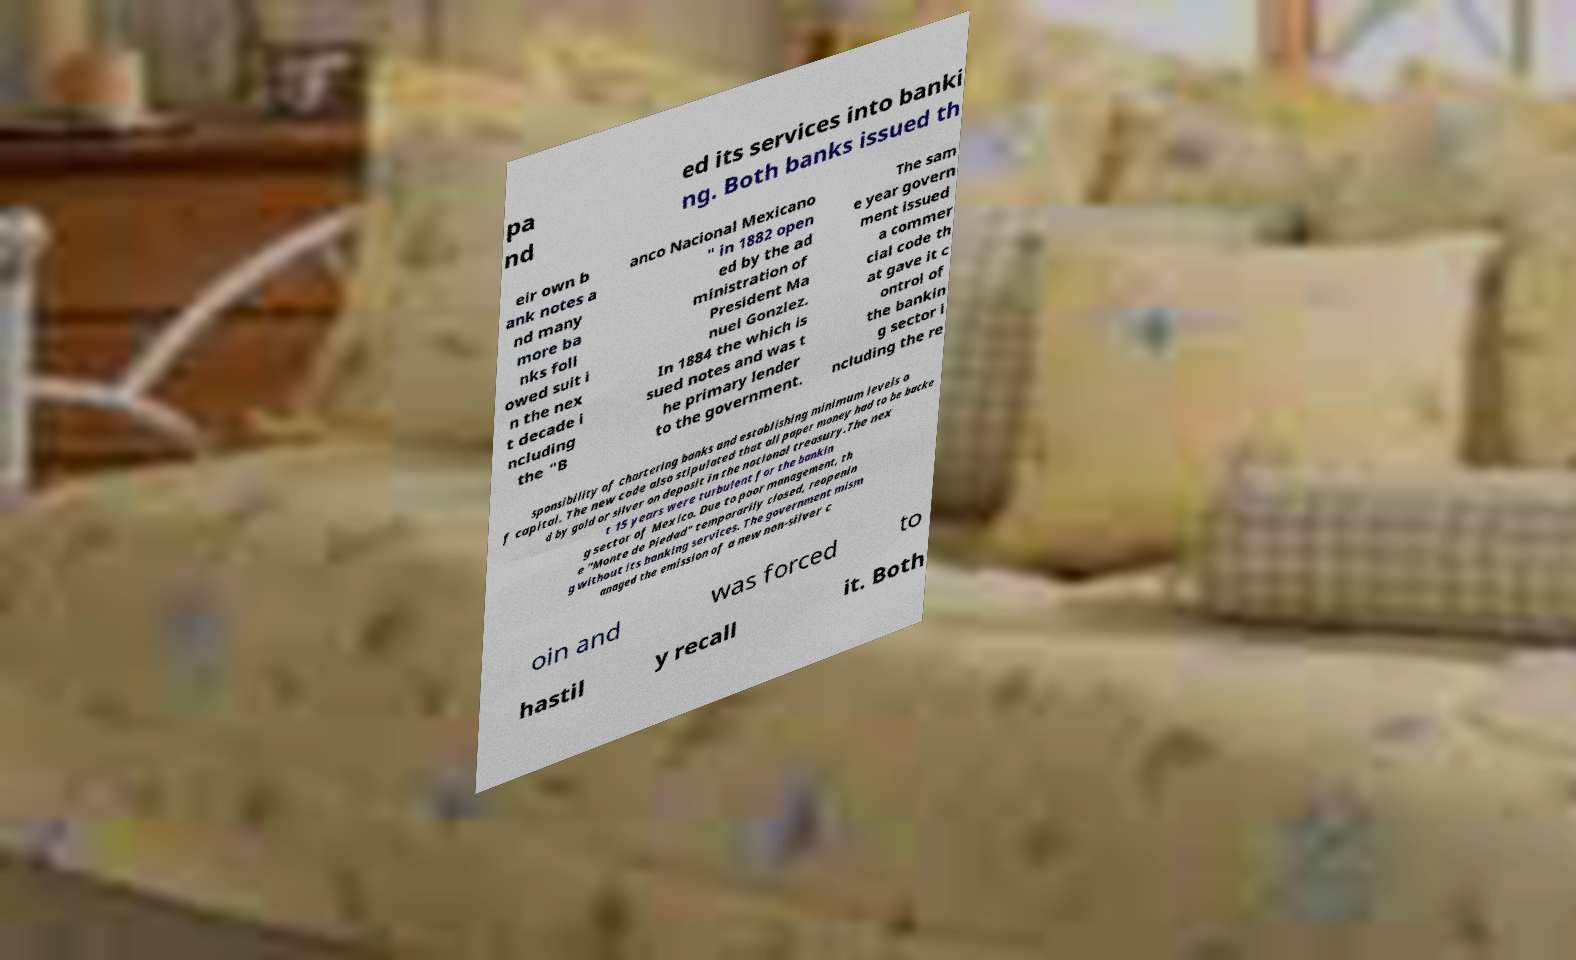Can you read and provide the text displayed in the image?This photo seems to have some interesting text. Can you extract and type it out for me? pa nd ed its services into banki ng. Both banks issued th eir own b ank notes a nd many more ba nks foll owed suit i n the nex t decade i ncluding the "B anco Nacional Mexicano " in 1882 open ed by the ad ministration of President Ma nuel Gonzlez. In 1884 the which is sued notes and was t he primary lender to the government. The sam e year govern ment issued a commer cial code th at gave it c ontrol of the bankin g sector i ncluding the re sponsibility of chartering banks and establishing minimum levels o f capital. The new code also stipulated that all paper money had to be backe d by gold or silver on deposit in the national treasury.The nex t 15 years were turbulent for the bankin g sector of Mexico. Due to poor management, th e "Monte de Piedad" temporarily closed, reopenin g without its banking services. The government mism anaged the emission of a new non-silver c oin and was forced to hastil y recall it. Both 